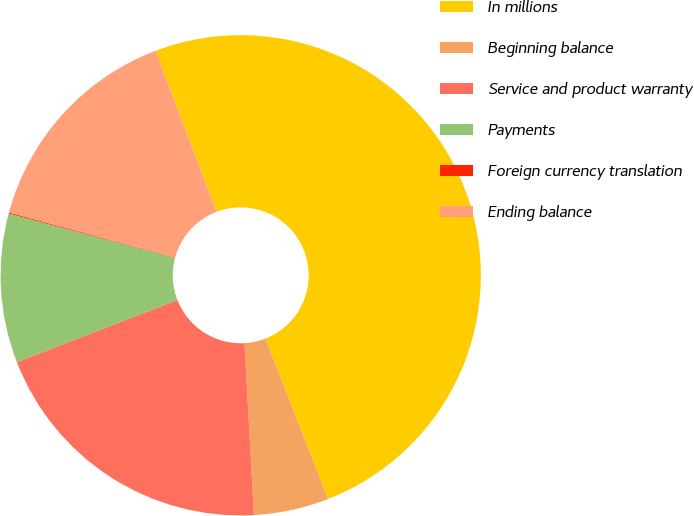<chart> <loc_0><loc_0><loc_500><loc_500><pie_chart><fcel>In millions<fcel>Beginning balance<fcel>Service and product warranty<fcel>Payments<fcel>Foreign currency translation<fcel>Ending balance<nl><fcel>49.86%<fcel>5.05%<fcel>19.99%<fcel>10.03%<fcel>0.07%<fcel>15.01%<nl></chart> 